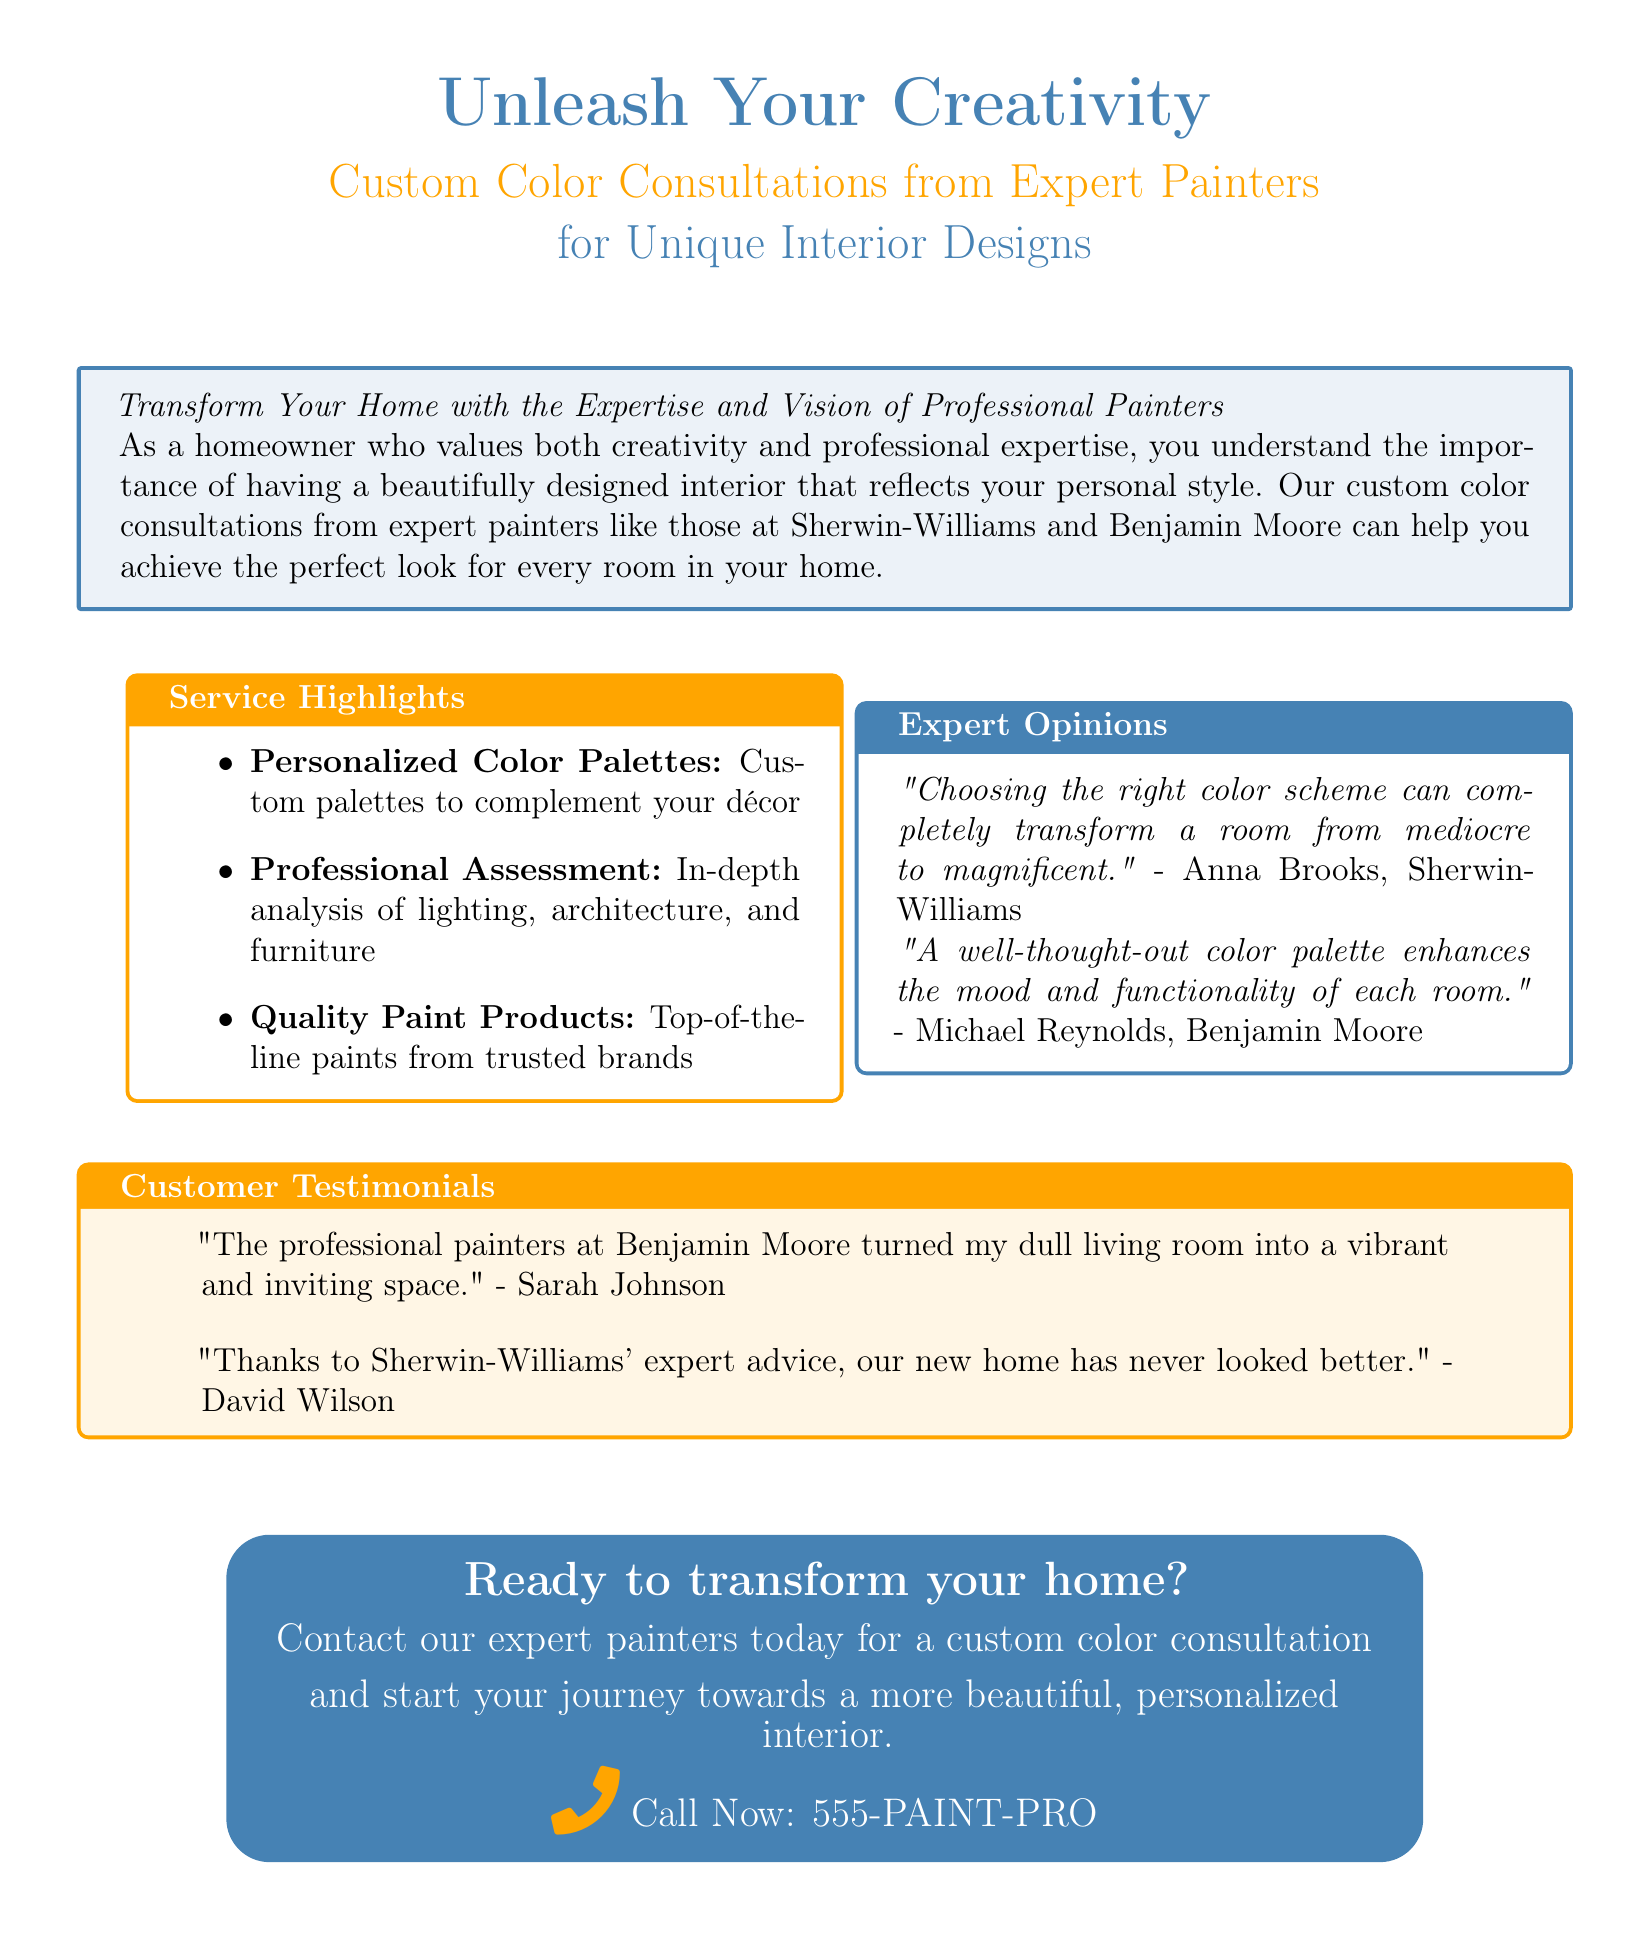What is the main service being offered? The advertisement is promoting custom color consultations for interior design from expert painters.
Answer: Custom color consultations Who are the expert painters mentioned? The document specifically lists Sherwin-Williams and Benjamin Moore as the expert painters.
Answer: Sherwin-Williams and Benjamin Moore What is one of the service highlights? The document mentions several highlights, one of which is the provision of personalized color palettes.
Answer: Personalized color palettes What quote is attributed to Anna Brooks? The advertisement includes a quote from Anna Brooks regarding the impact of color schemes on rooms.
Answer: "Choosing the right color scheme can completely transform a room from mediocre to magnificent." What is the contact number provided? The advertisement provides a specific contact number for consultations.
Answer: 555-PAINT-PRO What does Sarah Johnson say about her experience? Sarah Johnson shares a positive testimonial about her living room transformation by professionals.
Answer: "The professional painters at Benjamin Moore turned my dull living room into a vibrant and inviting space." What mood does a well-thought-out color palette enhance, according to Michael Reynolds? Michael Reynolds emphasizes that color palettes enhance mood and functionality.
Answer: Mood and functionality How are the paint products described? The document describes the paint products as top-of-the-line from trusted brands.
Answer: Top-of-the-line paints from trusted brands 